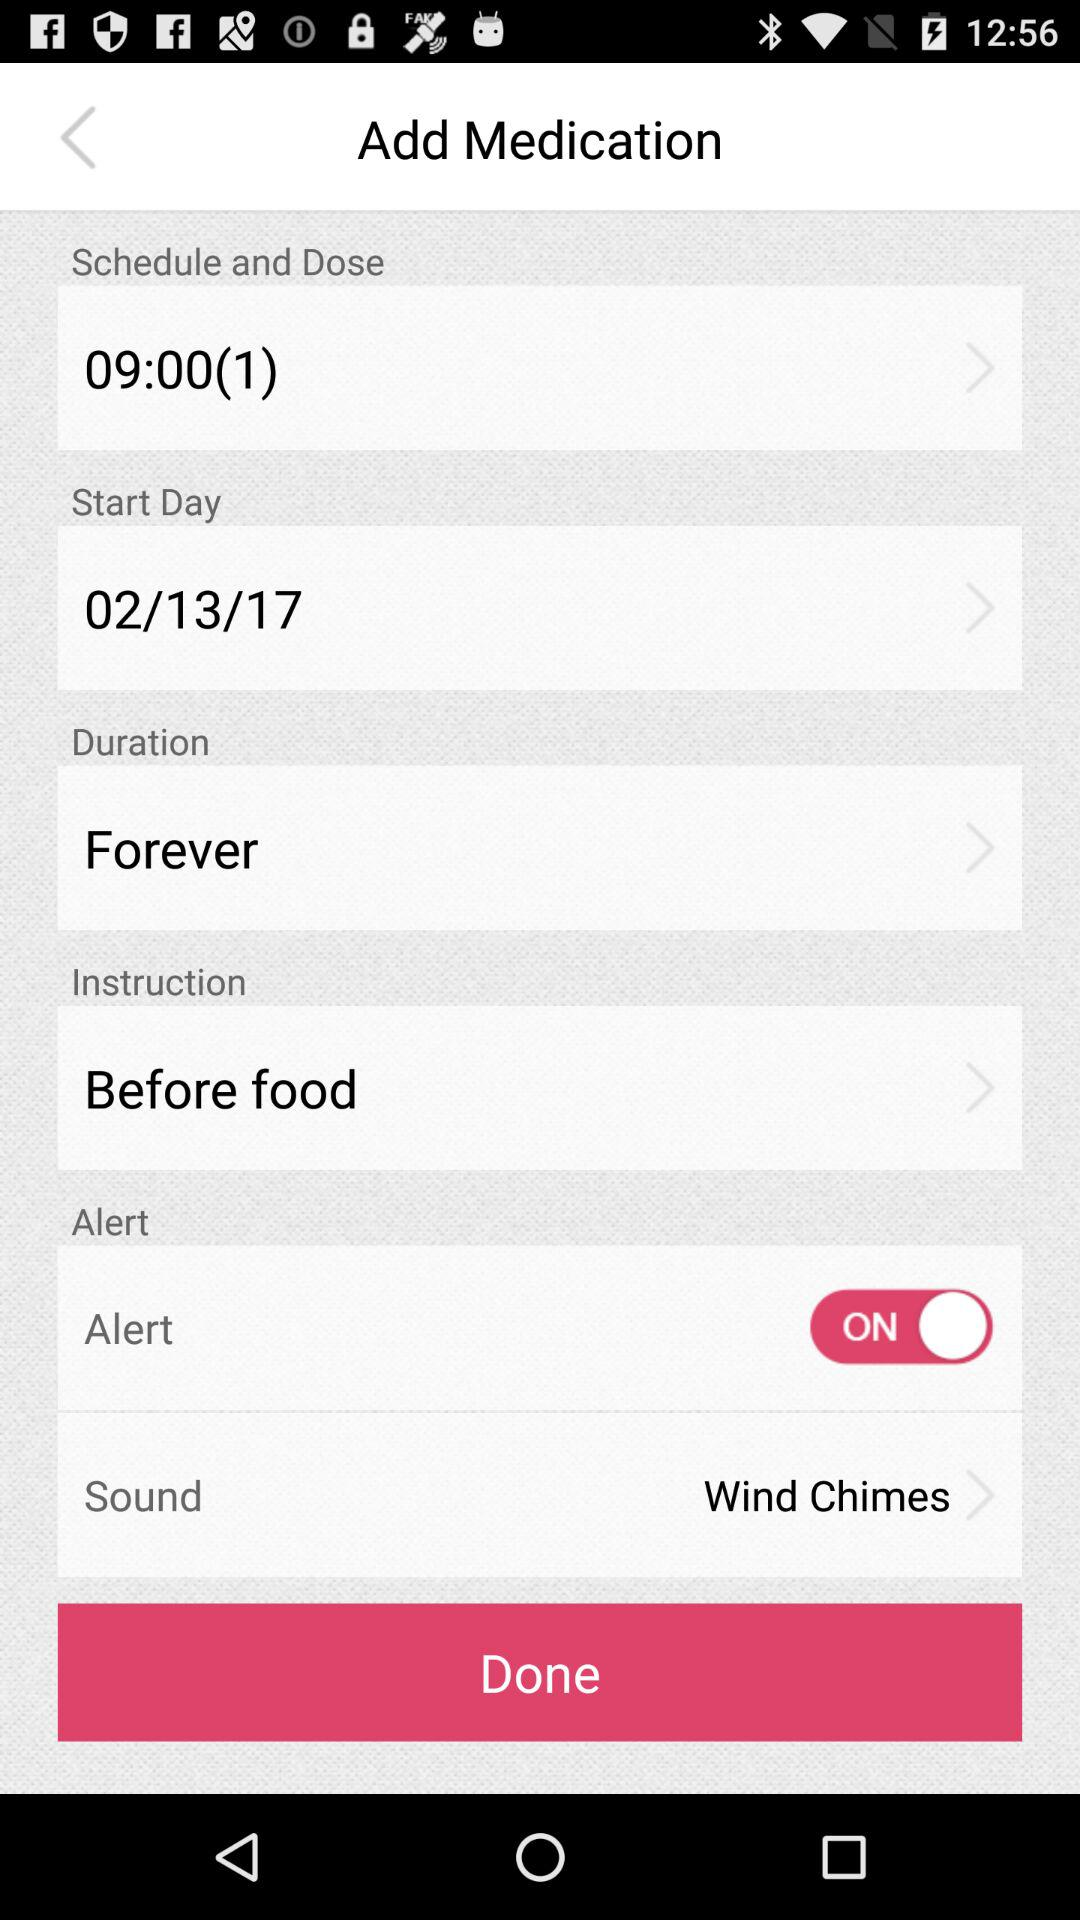Is the starting time in the morning or evening?
When the provided information is insufficient, respond with <no answer>. <no answer> 